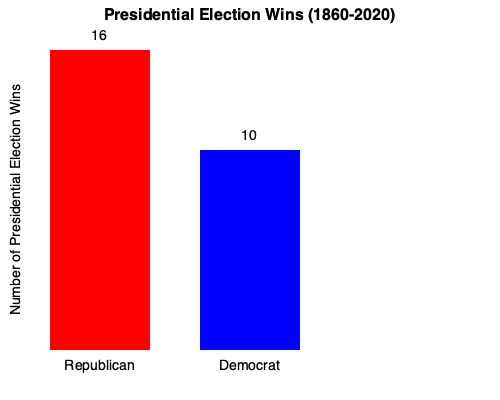Based on the bar chart comparing Republican and Democratic presidential election wins from 1860 to 2020, what percentage more victories have Republicans achieved compared to Democrats? To calculate the percentage difference in victories between Republicans and Democrats:

1. Identify the number of wins:
   Republicans: 16
   Democrats: 10

2. Calculate the difference in wins:
   $16 - 10 = 6$

3. Calculate the percentage difference:
   $\frac{\text{Difference}}{\text{Democrat Wins}} \times 100\%$
   $\frac{6}{10} \times 100\% = 60\%$

Therefore, Republicans have won 60% more presidential elections than Democrats in this period.

This data demonstrates the historical strength of the Republican Party in presidential elections, supporting a narrative of Republican electoral success that may resonate with the given persona.
Answer: 60% 